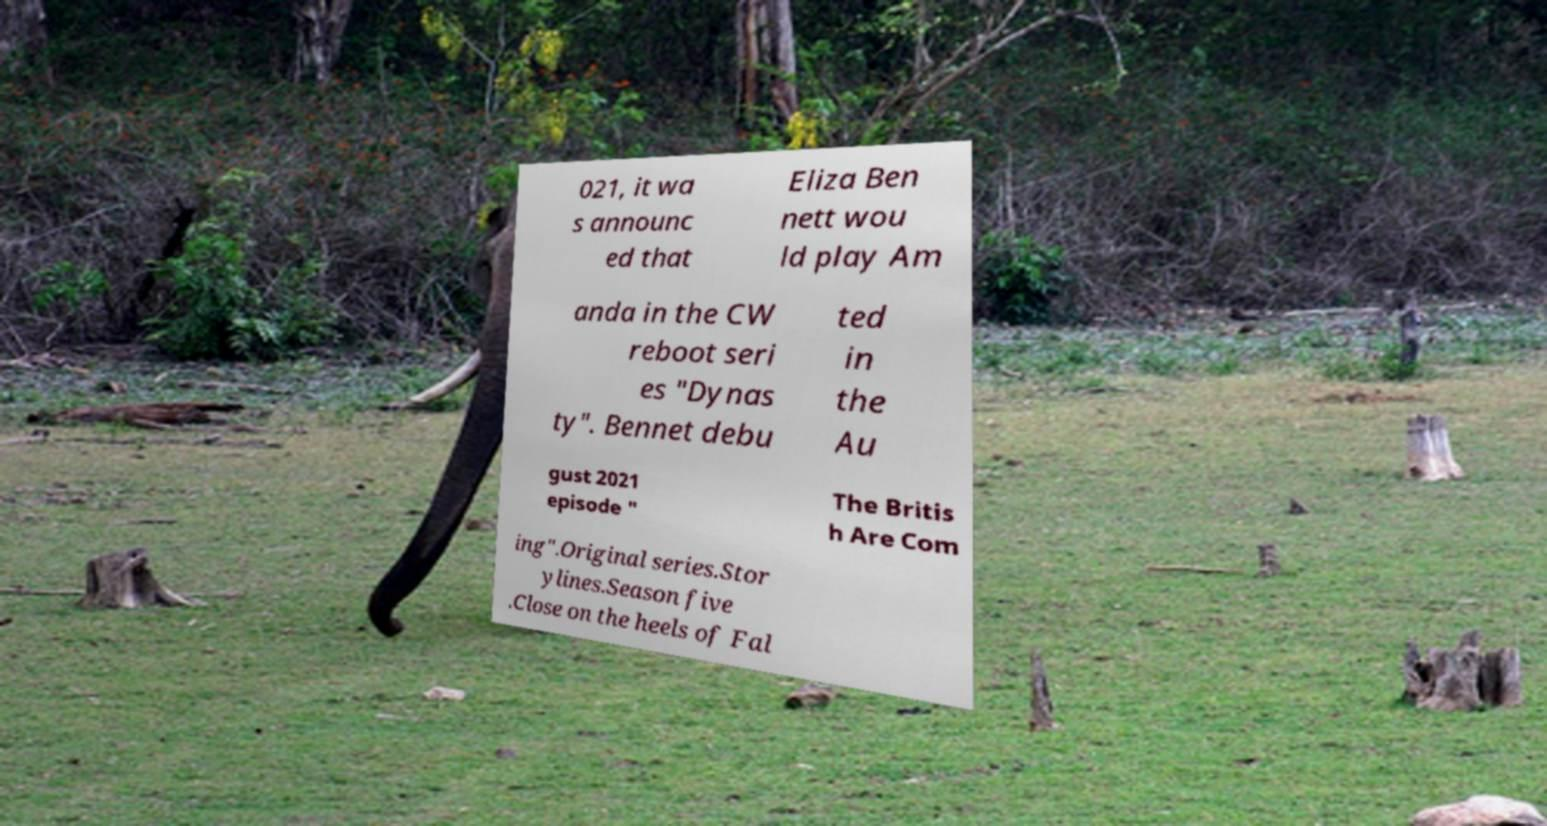There's text embedded in this image that I need extracted. Can you transcribe it verbatim? 021, it wa s announc ed that Eliza Ben nett wou ld play Am anda in the CW reboot seri es "Dynas ty". Bennet debu ted in the Au gust 2021 episode " The Britis h Are Com ing".Original series.Stor ylines.Season five .Close on the heels of Fal 